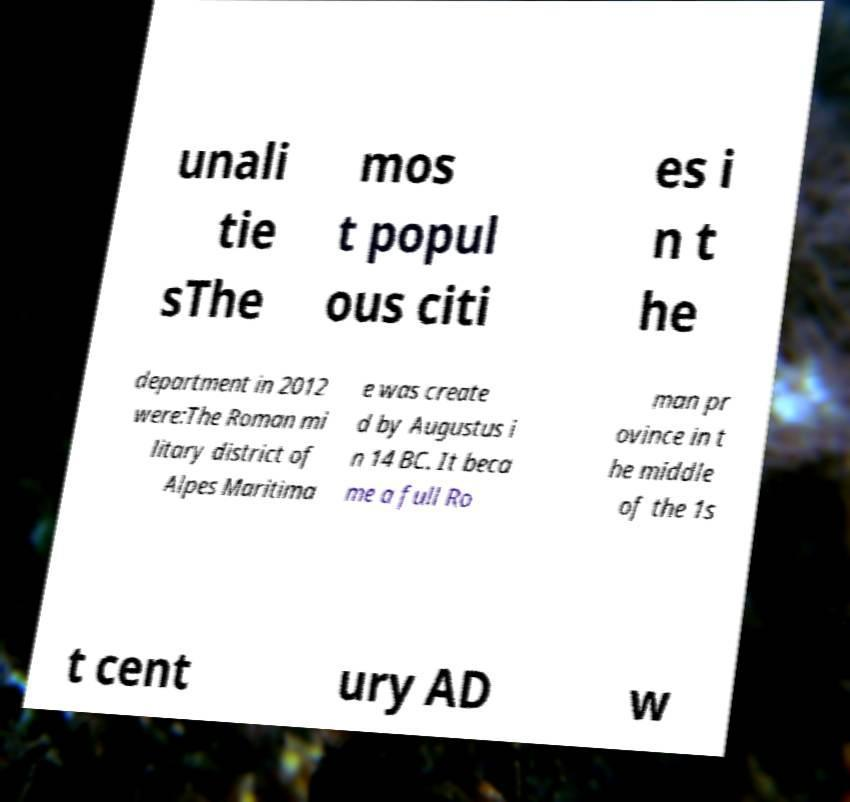Could you extract and type out the text from this image? unali tie sThe mos t popul ous citi es i n t he department in 2012 were:The Roman mi litary district of Alpes Maritima e was create d by Augustus i n 14 BC. It beca me a full Ro man pr ovince in t he middle of the 1s t cent ury AD w 